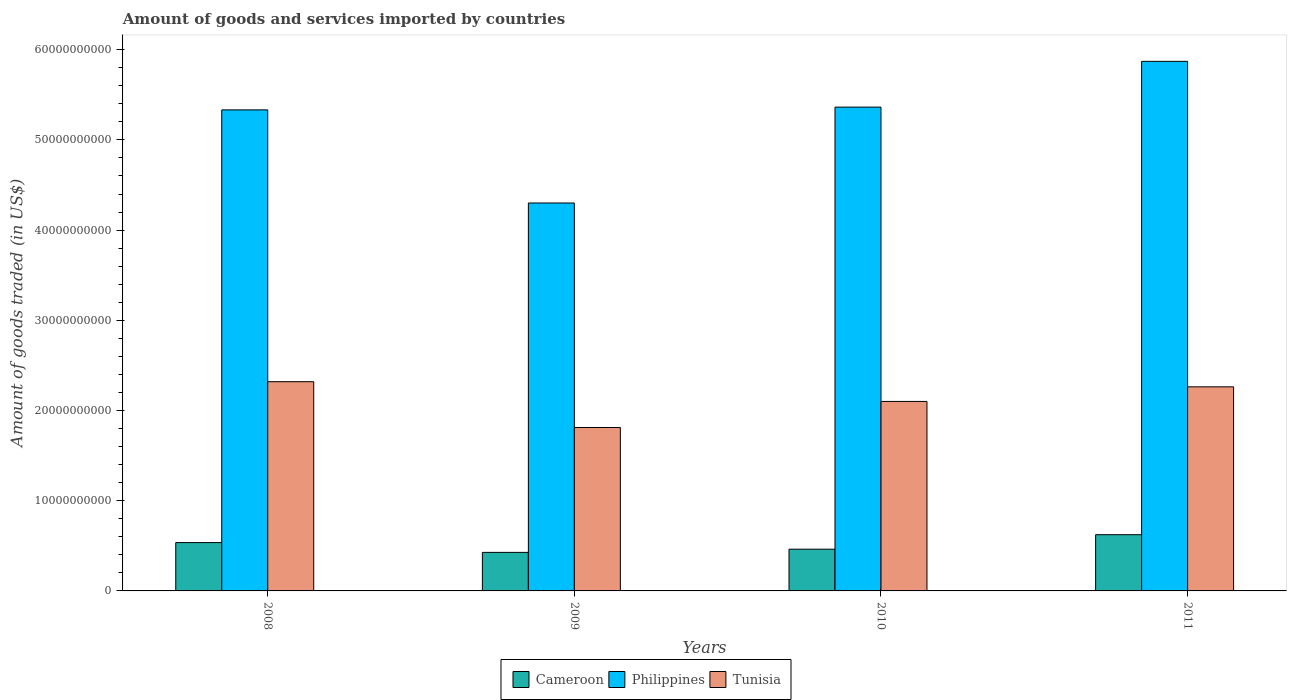How many different coloured bars are there?
Ensure brevity in your answer.  3. How many groups of bars are there?
Your response must be concise. 4. Are the number of bars on each tick of the X-axis equal?
Make the answer very short. Yes. How many bars are there on the 4th tick from the left?
Your answer should be very brief. 3. What is the total amount of goods and services imported in Philippines in 2010?
Ensure brevity in your answer.  5.36e+1. Across all years, what is the maximum total amount of goods and services imported in Cameroon?
Give a very brief answer. 6.23e+09. Across all years, what is the minimum total amount of goods and services imported in Cameroon?
Give a very brief answer. 4.27e+09. In which year was the total amount of goods and services imported in Philippines maximum?
Your response must be concise. 2011. What is the total total amount of goods and services imported in Philippines in the graph?
Your response must be concise. 2.09e+11. What is the difference between the total amount of goods and services imported in Tunisia in 2009 and that in 2010?
Ensure brevity in your answer.  -2.89e+09. What is the difference between the total amount of goods and services imported in Philippines in 2008 and the total amount of goods and services imported in Tunisia in 2010?
Your answer should be very brief. 3.23e+1. What is the average total amount of goods and services imported in Philippines per year?
Keep it short and to the point. 5.22e+1. In the year 2009, what is the difference between the total amount of goods and services imported in Tunisia and total amount of goods and services imported in Cameroon?
Provide a short and direct response. 1.38e+1. In how many years, is the total amount of goods and services imported in Philippines greater than 2000000000 US$?
Offer a very short reply. 4. What is the ratio of the total amount of goods and services imported in Philippines in 2008 to that in 2011?
Ensure brevity in your answer.  0.91. Is the total amount of goods and services imported in Cameroon in 2008 less than that in 2009?
Ensure brevity in your answer.  No. What is the difference between the highest and the second highest total amount of goods and services imported in Philippines?
Ensure brevity in your answer.  5.07e+09. What is the difference between the highest and the lowest total amount of goods and services imported in Tunisia?
Offer a terse response. 5.08e+09. What does the 1st bar from the left in 2010 represents?
Provide a short and direct response. Cameroon. Are the values on the major ticks of Y-axis written in scientific E-notation?
Offer a very short reply. No. Does the graph contain any zero values?
Keep it short and to the point. No. Where does the legend appear in the graph?
Make the answer very short. Bottom center. How many legend labels are there?
Your answer should be very brief. 3. How are the legend labels stacked?
Your answer should be compact. Horizontal. What is the title of the graph?
Offer a very short reply. Amount of goods and services imported by countries. Does "Germany" appear as one of the legend labels in the graph?
Provide a succinct answer. No. What is the label or title of the X-axis?
Your answer should be compact. Years. What is the label or title of the Y-axis?
Ensure brevity in your answer.  Amount of goods traded (in US$). What is the Amount of goods traded (in US$) in Cameroon in 2008?
Provide a short and direct response. 5.36e+09. What is the Amount of goods traded (in US$) in Philippines in 2008?
Offer a very short reply. 5.33e+1. What is the Amount of goods traded (in US$) of Tunisia in 2008?
Provide a succinct answer. 2.32e+1. What is the Amount of goods traded (in US$) in Cameroon in 2009?
Offer a terse response. 4.27e+09. What is the Amount of goods traded (in US$) in Philippines in 2009?
Give a very brief answer. 4.30e+1. What is the Amount of goods traded (in US$) in Tunisia in 2009?
Provide a succinct answer. 1.81e+1. What is the Amount of goods traded (in US$) of Cameroon in 2010?
Provide a short and direct response. 4.63e+09. What is the Amount of goods traded (in US$) of Philippines in 2010?
Your response must be concise. 5.36e+1. What is the Amount of goods traded (in US$) of Tunisia in 2010?
Keep it short and to the point. 2.10e+1. What is the Amount of goods traded (in US$) of Cameroon in 2011?
Offer a very short reply. 6.23e+09. What is the Amount of goods traded (in US$) in Philippines in 2011?
Provide a short and direct response. 5.87e+1. What is the Amount of goods traded (in US$) in Tunisia in 2011?
Your answer should be compact. 2.26e+1. Across all years, what is the maximum Amount of goods traded (in US$) of Cameroon?
Offer a very short reply. 6.23e+09. Across all years, what is the maximum Amount of goods traded (in US$) of Philippines?
Offer a very short reply. 5.87e+1. Across all years, what is the maximum Amount of goods traded (in US$) in Tunisia?
Offer a terse response. 2.32e+1. Across all years, what is the minimum Amount of goods traded (in US$) of Cameroon?
Give a very brief answer. 4.27e+09. Across all years, what is the minimum Amount of goods traded (in US$) of Philippines?
Offer a terse response. 4.30e+1. Across all years, what is the minimum Amount of goods traded (in US$) in Tunisia?
Your answer should be compact. 1.81e+1. What is the total Amount of goods traded (in US$) of Cameroon in the graph?
Offer a very short reply. 2.05e+1. What is the total Amount of goods traded (in US$) in Philippines in the graph?
Make the answer very short. 2.09e+11. What is the total Amount of goods traded (in US$) of Tunisia in the graph?
Provide a short and direct response. 8.49e+1. What is the difference between the Amount of goods traded (in US$) in Cameroon in 2008 and that in 2009?
Give a very brief answer. 1.09e+09. What is the difference between the Amount of goods traded (in US$) of Philippines in 2008 and that in 2009?
Offer a terse response. 1.03e+1. What is the difference between the Amount of goods traded (in US$) of Tunisia in 2008 and that in 2009?
Your response must be concise. 5.08e+09. What is the difference between the Amount of goods traded (in US$) of Cameroon in 2008 and that in 2010?
Make the answer very short. 7.32e+08. What is the difference between the Amount of goods traded (in US$) of Philippines in 2008 and that in 2010?
Make the answer very short. -3.07e+08. What is the difference between the Amount of goods traded (in US$) in Tunisia in 2008 and that in 2010?
Keep it short and to the point. 2.19e+09. What is the difference between the Amount of goods traded (in US$) of Cameroon in 2008 and that in 2011?
Offer a terse response. -8.75e+08. What is the difference between the Amount of goods traded (in US$) of Philippines in 2008 and that in 2011?
Offer a terse response. -5.38e+09. What is the difference between the Amount of goods traded (in US$) of Tunisia in 2008 and that in 2011?
Keep it short and to the point. 5.71e+08. What is the difference between the Amount of goods traded (in US$) of Cameroon in 2009 and that in 2010?
Offer a terse response. -3.54e+08. What is the difference between the Amount of goods traded (in US$) in Philippines in 2009 and that in 2010?
Provide a succinct answer. -1.06e+1. What is the difference between the Amount of goods traded (in US$) in Tunisia in 2009 and that in 2010?
Offer a very short reply. -2.89e+09. What is the difference between the Amount of goods traded (in US$) in Cameroon in 2009 and that in 2011?
Offer a terse response. -1.96e+09. What is the difference between the Amount of goods traded (in US$) in Philippines in 2009 and that in 2011?
Offer a very short reply. -1.57e+1. What is the difference between the Amount of goods traded (in US$) of Tunisia in 2009 and that in 2011?
Make the answer very short. -4.51e+09. What is the difference between the Amount of goods traded (in US$) of Cameroon in 2010 and that in 2011?
Offer a very short reply. -1.61e+09. What is the difference between the Amount of goods traded (in US$) in Philippines in 2010 and that in 2011?
Provide a short and direct response. -5.07e+09. What is the difference between the Amount of goods traded (in US$) of Tunisia in 2010 and that in 2011?
Provide a succinct answer. -1.62e+09. What is the difference between the Amount of goods traded (in US$) in Cameroon in 2008 and the Amount of goods traded (in US$) in Philippines in 2009?
Your answer should be very brief. -3.76e+1. What is the difference between the Amount of goods traded (in US$) in Cameroon in 2008 and the Amount of goods traded (in US$) in Tunisia in 2009?
Provide a short and direct response. -1.28e+1. What is the difference between the Amount of goods traded (in US$) in Philippines in 2008 and the Amount of goods traded (in US$) in Tunisia in 2009?
Your response must be concise. 3.52e+1. What is the difference between the Amount of goods traded (in US$) in Cameroon in 2008 and the Amount of goods traded (in US$) in Philippines in 2010?
Offer a terse response. -4.83e+1. What is the difference between the Amount of goods traded (in US$) in Cameroon in 2008 and the Amount of goods traded (in US$) in Tunisia in 2010?
Your answer should be very brief. -1.56e+1. What is the difference between the Amount of goods traded (in US$) of Philippines in 2008 and the Amount of goods traded (in US$) of Tunisia in 2010?
Your answer should be compact. 3.23e+1. What is the difference between the Amount of goods traded (in US$) in Cameroon in 2008 and the Amount of goods traded (in US$) in Philippines in 2011?
Your answer should be very brief. -5.33e+1. What is the difference between the Amount of goods traded (in US$) in Cameroon in 2008 and the Amount of goods traded (in US$) in Tunisia in 2011?
Your answer should be very brief. -1.73e+1. What is the difference between the Amount of goods traded (in US$) in Philippines in 2008 and the Amount of goods traded (in US$) in Tunisia in 2011?
Your answer should be compact. 3.07e+1. What is the difference between the Amount of goods traded (in US$) of Cameroon in 2009 and the Amount of goods traded (in US$) of Philippines in 2010?
Make the answer very short. -4.94e+1. What is the difference between the Amount of goods traded (in US$) of Cameroon in 2009 and the Amount of goods traded (in US$) of Tunisia in 2010?
Your answer should be compact. -1.67e+1. What is the difference between the Amount of goods traded (in US$) of Philippines in 2009 and the Amount of goods traded (in US$) of Tunisia in 2010?
Your answer should be very brief. 2.20e+1. What is the difference between the Amount of goods traded (in US$) in Cameroon in 2009 and the Amount of goods traded (in US$) in Philippines in 2011?
Provide a short and direct response. -5.44e+1. What is the difference between the Amount of goods traded (in US$) in Cameroon in 2009 and the Amount of goods traded (in US$) in Tunisia in 2011?
Provide a short and direct response. -1.84e+1. What is the difference between the Amount of goods traded (in US$) of Philippines in 2009 and the Amount of goods traded (in US$) of Tunisia in 2011?
Ensure brevity in your answer.  2.04e+1. What is the difference between the Amount of goods traded (in US$) in Cameroon in 2010 and the Amount of goods traded (in US$) in Philippines in 2011?
Offer a very short reply. -5.41e+1. What is the difference between the Amount of goods traded (in US$) of Cameroon in 2010 and the Amount of goods traded (in US$) of Tunisia in 2011?
Give a very brief answer. -1.80e+1. What is the difference between the Amount of goods traded (in US$) in Philippines in 2010 and the Amount of goods traded (in US$) in Tunisia in 2011?
Provide a succinct answer. 3.10e+1. What is the average Amount of goods traded (in US$) of Cameroon per year?
Offer a terse response. 5.12e+09. What is the average Amount of goods traded (in US$) in Philippines per year?
Give a very brief answer. 5.22e+1. What is the average Amount of goods traded (in US$) of Tunisia per year?
Keep it short and to the point. 2.12e+1. In the year 2008, what is the difference between the Amount of goods traded (in US$) of Cameroon and Amount of goods traded (in US$) of Philippines?
Ensure brevity in your answer.  -4.80e+1. In the year 2008, what is the difference between the Amount of goods traded (in US$) in Cameroon and Amount of goods traded (in US$) in Tunisia?
Provide a short and direct response. -1.78e+1. In the year 2008, what is the difference between the Amount of goods traded (in US$) of Philippines and Amount of goods traded (in US$) of Tunisia?
Provide a short and direct response. 3.01e+1. In the year 2009, what is the difference between the Amount of goods traded (in US$) of Cameroon and Amount of goods traded (in US$) of Philippines?
Provide a short and direct response. -3.87e+1. In the year 2009, what is the difference between the Amount of goods traded (in US$) in Cameroon and Amount of goods traded (in US$) in Tunisia?
Ensure brevity in your answer.  -1.38e+1. In the year 2009, what is the difference between the Amount of goods traded (in US$) of Philippines and Amount of goods traded (in US$) of Tunisia?
Offer a terse response. 2.49e+1. In the year 2010, what is the difference between the Amount of goods traded (in US$) of Cameroon and Amount of goods traded (in US$) of Philippines?
Provide a succinct answer. -4.90e+1. In the year 2010, what is the difference between the Amount of goods traded (in US$) in Cameroon and Amount of goods traded (in US$) in Tunisia?
Give a very brief answer. -1.64e+1. In the year 2010, what is the difference between the Amount of goods traded (in US$) in Philippines and Amount of goods traded (in US$) in Tunisia?
Your answer should be very brief. 3.26e+1. In the year 2011, what is the difference between the Amount of goods traded (in US$) in Cameroon and Amount of goods traded (in US$) in Philippines?
Offer a very short reply. -5.25e+1. In the year 2011, what is the difference between the Amount of goods traded (in US$) in Cameroon and Amount of goods traded (in US$) in Tunisia?
Provide a short and direct response. -1.64e+1. In the year 2011, what is the difference between the Amount of goods traded (in US$) in Philippines and Amount of goods traded (in US$) in Tunisia?
Provide a short and direct response. 3.61e+1. What is the ratio of the Amount of goods traded (in US$) of Cameroon in 2008 to that in 2009?
Provide a short and direct response. 1.25. What is the ratio of the Amount of goods traded (in US$) of Philippines in 2008 to that in 2009?
Ensure brevity in your answer.  1.24. What is the ratio of the Amount of goods traded (in US$) in Tunisia in 2008 to that in 2009?
Your answer should be compact. 1.28. What is the ratio of the Amount of goods traded (in US$) of Cameroon in 2008 to that in 2010?
Keep it short and to the point. 1.16. What is the ratio of the Amount of goods traded (in US$) in Philippines in 2008 to that in 2010?
Provide a succinct answer. 0.99. What is the ratio of the Amount of goods traded (in US$) of Tunisia in 2008 to that in 2010?
Provide a succinct answer. 1.1. What is the ratio of the Amount of goods traded (in US$) of Cameroon in 2008 to that in 2011?
Give a very brief answer. 0.86. What is the ratio of the Amount of goods traded (in US$) of Philippines in 2008 to that in 2011?
Ensure brevity in your answer.  0.91. What is the ratio of the Amount of goods traded (in US$) of Tunisia in 2008 to that in 2011?
Give a very brief answer. 1.03. What is the ratio of the Amount of goods traded (in US$) of Cameroon in 2009 to that in 2010?
Provide a short and direct response. 0.92. What is the ratio of the Amount of goods traded (in US$) of Philippines in 2009 to that in 2010?
Your answer should be compact. 0.8. What is the ratio of the Amount of goods traded (in US$) of Tunisia in 2009 to that in 2010?
Your answer should be compact. 0.86. What is the ratio of the Amount of goods traded (in US$) in Cameroon in 2009 to that in 2011?
Keep it short and to the point. 0.69. What is the ratio of the Amount of goods traded (in US$) in Philippines in 2009 to that in 2011?
Provide a succinct answer. 0.73. What is the ratio of the Amount of goods traded (in US$) of Tunisia in 2009 to that in 2011?
Keep it short and to the point. 0.8. What is the ratio of the Amount of goods traded (in US$) of Cameroon in 2010 to that in 2011?
Your response must be concise. 0.74. What is the ratio of the Amount of goods traded (in US$) in Philippines in 2010 to that in 2011?
Keep it short and to the point. 0.91. What is the ratio of the Amount of goods traded (in US$) of Tunisia in 2010 to that in 2011?
Make the answer very short. 0.93. What is the difference between the highest and the second highest Amount of goods traded (in US$) in Cameroon?
Provide a short and direct response. 8.75e+08. What is the difference between the highest and the second highest Amount of goods traded (in US$) in Philippines?
Make the answer very short. 5.07e+09. What is the difference between the highest and the second highest Amount of goods traded (in US$) of Tunisia?
Provide a succinct answer. 5.71e+08. What is the difference between the highest and the lowest Amount of goods traded (in US$) of Cameroon?
Ensure brevity in your answer.  1.96e+09. What is the difference between the highest and the lowest Amount of goods traded (in US$) of Philippines?
Ensure brevity in your answer.  1.57e+1. What is the difference between the highest and the lowest Amount of goods traded (in US$) of Tunisia?
Your answer should be very brief. 5.08e+09. 